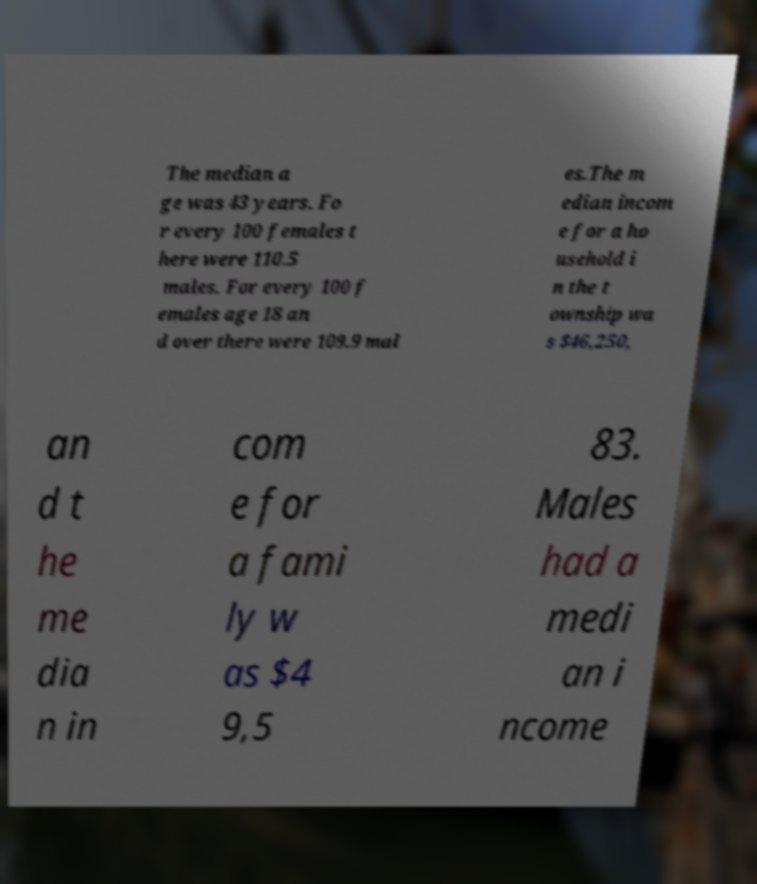Can you read and provide the text displayed in the image?This photo seems to have some interesting text. Can you extract and type it out for me? The median a ge was 43 years. Fo r every 100 females t here were 110.5 males. For every 100 f emales age 18 an d over there were 109.9 mal es.The m edian incom e for a ho usehold i n the t ownship wa s $46,250, an d t he me dia n in com e for a fami ly w as $4 9,5 83. Males had a medi an i ncome 